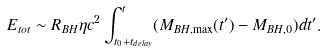Convert formula to latex. <formula><loc_0><loc_0><loc_500><loc_500>E _ { t o t } \sim R _ { B H } \eta c ^ { 2 } \int _ { t _ { 0 } + t _ { d e l a y } } ^ { t } ( M _ { B H , \max } ( t ^ { \prime } ) - M _ { B H , 0 } ) d t ^ { \prime } .</formula> 